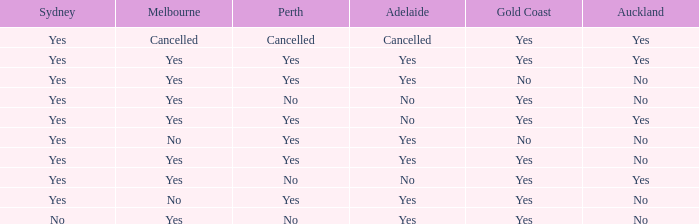What is The Melbourne with a No- Gold Coast Yes, No. 